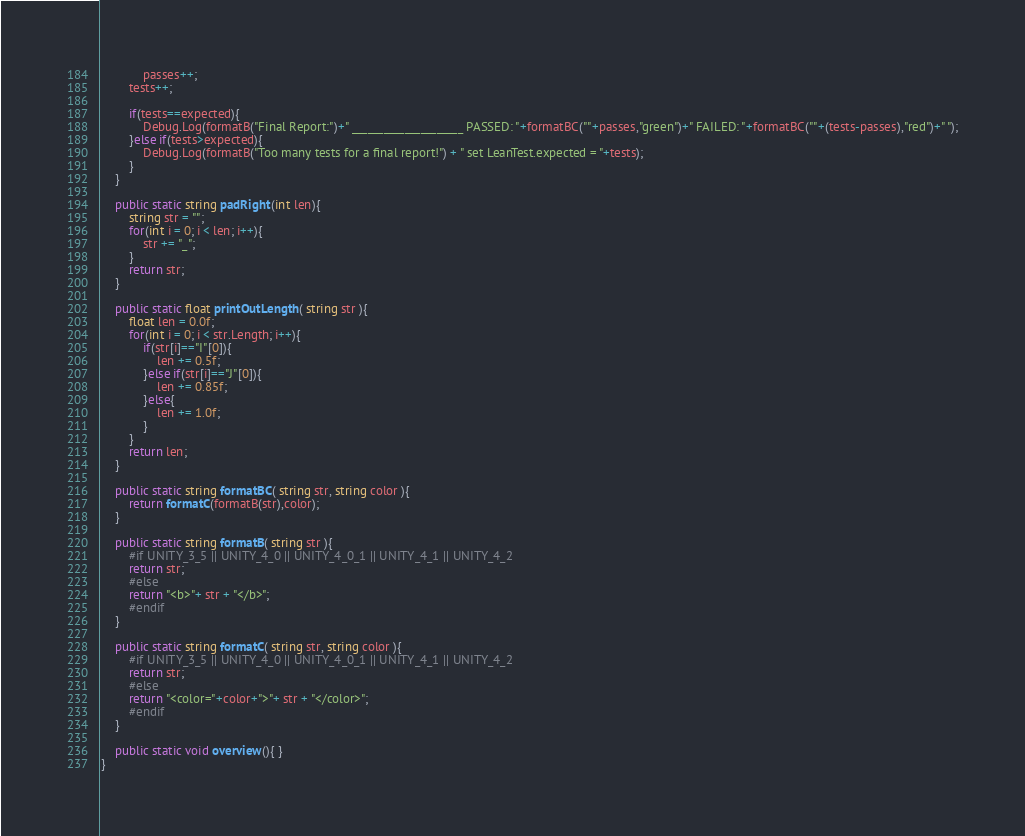Convert code to text. <code><loc_0><loc_0><loc_500><loc_500><_C#_>			passes++;
		tests++;
		
		if(tests==expected){
			Debug.Log(formatB("Final Report:")+" _____________________ PASSED: "+formatBC(""+passes,"green")+" FAILED: "+formatBC(""+(tests-passes),"red")+" ");
		}else if(tests>expected){
			Debug.Log(formatB("Too many tests for a final report!") + " set LeanTest.expected = "+tests);
		}
	}
	
	public static string padRight(int len){
		string str = "";
		for(int i = 0; i < len; i++){
			str += "_";
		}
		return str;
	}
	
	public static float printOutLength( string str ){
		float len = 0.0f;
		for(int i = 0; i < str.Length; i++){
			if(str[i]=="I"[0]){
				len += 0.5f;
			}else if(str[i]=="J"[0]){
				len += 0.85f;
			}else{
				len += 1.0f;
			}
		}
		return len;
	}
	
	public static string formatBC( string str, string color ){
		return formatC(formatB(str),color);
	}
	
	public static string formatB( string str ){
		#if UNITY_3_5 || UNITY_4_0 || UNITY_4_0_1 || UNITY_4_1 || UNITY_4_2
		return str;
		#else
		return "<b>"+ str + "</b>";
		#endif
	}
	
	public static string formatC( string str, string color ){
		#if UNITY_3_5 || UNITY_4_0 || UNITY_4_0_1 || UNITY_4_1 || UNITY_4_2
		return str;
		#else
		return "<color="+color+">"+ str + "</color>";
		#endif
	}
	
	public static void overview(){ }
}
</code> 